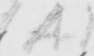What text is written in this handwritten line? ( A ) 